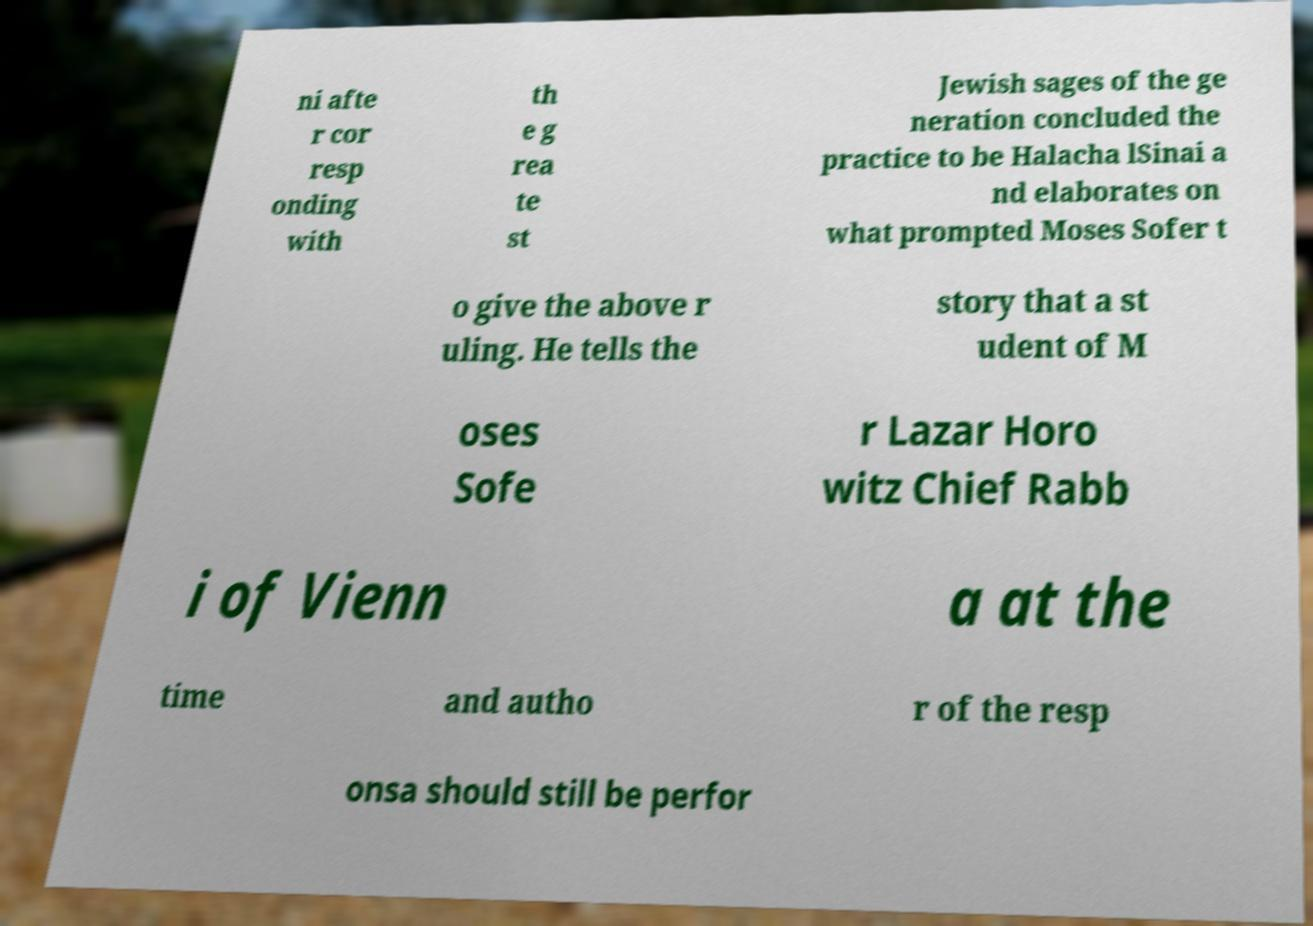Could you assist in decoding the text presented in this image and type it out clearly? ni afte r cor resp onding with th e g rea te st Jewish sages of the ge neration concluded the practice to be Halacha lSinai a nd elaborates on what prompted Moses Sofer t o give the above r uling. He tells the story that a st udent of M oses Sofe r Lazar Horo witz Chief Rabb i of Vienn a at the time and autho r of the resp onsa should still be perfor 